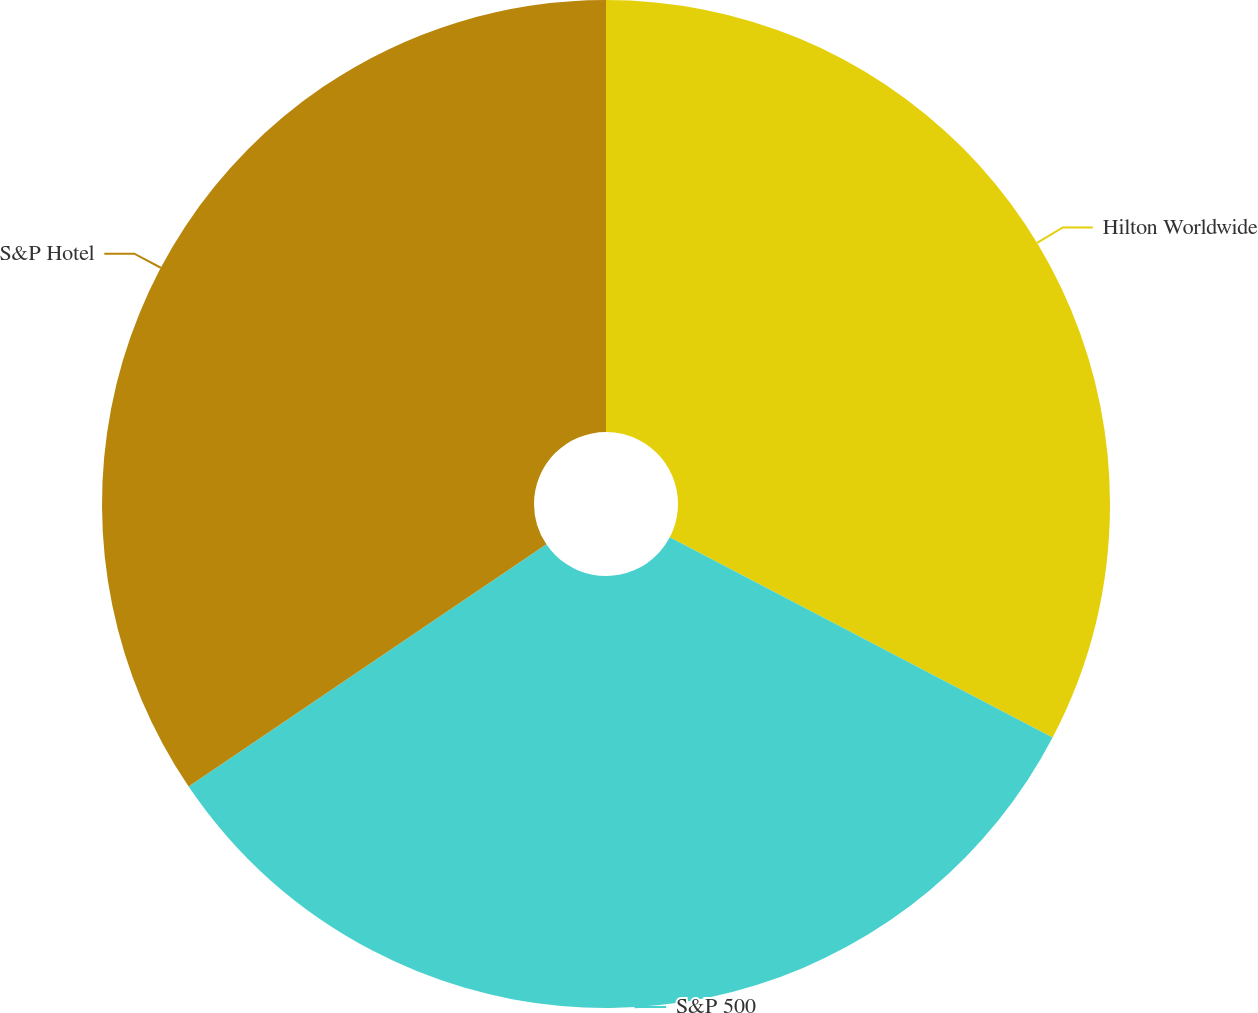<chart> <loc_0><loc_0><loc_500><loc_500><pie_chart><fcel>Hilton Worldwide<fcel>S&P 500<fcel>S&P Hotel<nl><fcel>32.67%<fcel>32.86%<fcel>34.47%<nl></chart> 